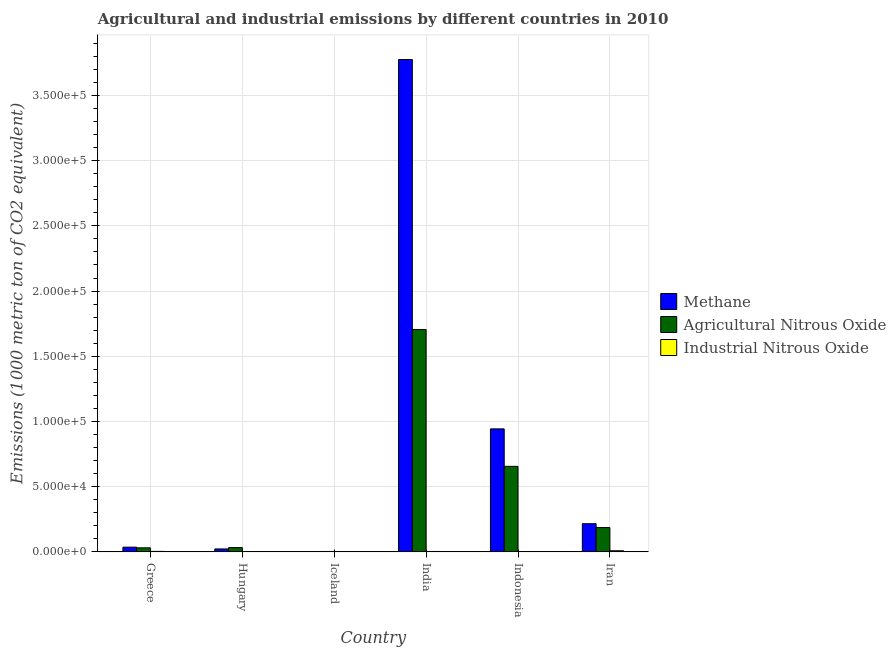How many different coloured bars are there?
Your answer should be very brief. 3. How many groups of bars are there?
Give a very brief answer. 6. How many bars are there on the 1st tick from the right?
Give a very brief answer. 3. What is the label of the 5th group of bars from the left?
Provide a short and direct response. Indonesia. What is the amount of agricultural nitrous oxide emissions in Iceland?
Ensure brevity in your answer.  311.8. Across all countries, what is the maximum amount of agricultural nitrous oxide emissions?
Give a very brief answer. 1.71e+05. Across all countries, what is the minimum amount of industrial nitrous oxide emissions?
Offer a very short reply. 12.5. In which country was the amount of industrial nitrous oxide emissions maximum?
Ensure brevity in your answer.  Iran. In which country was the amount of agricultural nitrous oxide emissions minimum?
Your answer should be compact. Iceland. What is the total amount of methane emissions in the graph?
Give a very brief answer. 5.00e+05. What is the difference between the amount of methane emissions in Hungary and that in Indonesia?
Offer a very short reply. -9.21e+04. What is the difference between the amount of industrial nitrous oxide emissions in Iceland and the amount of agricultural nitrous oxide emissions in Greece?
Your answer should be compact. -3089.4. What is the average amount of industrial nitrous oxide emissions per country?
Make the answer very short. 303.15. What is the difference between the amount of industrial nitrous oxide emissions and amount of agricultural nitrous oxide emissions in Indonesia?
Offer a very short reply. -6.54e+04. What is the ratio of the amount of agricultural nitrous oxide emissions in Iceland to that in Iran?
Offer a very short reply. 0.02. What is the difference between the highest and the second highest amount of agricultural nitrous oxide emissions?
Keep it short and to the point. 1.05e+05. What is the difference between the highest and the lowest amount of methane emissions?
Your answer should be very brief. 3.77e+05. What does the 1st bar from the left in Hungary represents?
Your response must be concise. Methane. What does the 3rd bar from the right in India represents?
Ensure brevity in your answer.  Methane. Is it the case that in every country, the sum of the amount of methane emissions and amount of agricultural nitrous oxide emissions is greater than the amount of industrial nitrous oxide emissions?
Make the answer very short. Yes. How many countries are there in the graph?
Your answer should be compact. 6. Does the graph contain any zero values?
Offer a terse response. No. Does the graph contain grids?
Your response must be concise. Yes. How are the legend labels stacked?
Offer a terse response. Vertical. What is the title of the graph?
Offer a terse response. Agricultural and industrial emissions by different countries in 2010. What is the label or title of the Y-axis?
Give a very brief answer. Emissions (1000 metric ton of CO2 equivalent). What is the Emissions (1000 metric ton of CO2 equivalent) of Methane in Greece?
Make the answer very short. 3622.4. What is the Emissions (1000 metric ton of CO2 equivalent) in Agricultural Nitrous Oxide in Greece?
Offer a terse response. 3107.1. What is the Emissions (1000 metric ton of CO2 equivalent) in Industrial Nitrous Oxide in Greece?
Ensure brevity in your answer.  372.7. What is the Emissions (1000 metric ton of CO2 equivalent) of Methane in Hungary?
Your response must be concise. 2250. What is the Emissions (1000 metric ton of CO2 equivalent) in Agricultural Nitrous Oxide in Hungary?
Make the answer very short. 3293.7. What is the Emissions (1000 metric ton of CO2 equivalent) of Methane in Iceland?
Provide a succinct answer. 212.4. What is the Emissions (1000 metric ton of CO2 equivalent) in Agricultural Nitrous Oxide in Iceland?
Provide a short and direct response. 311.8. What is the Emissions (1000 metric ton of CO2 equivalent) in Industrial Nitrous Oxide in Iceland?
Your answer should be compact. 17.7. What is the Emissions (1000 metric ton of CO2 equivalent) of Methane in India?
Ensure brevity in your answer.  3.78e+05. What is the Emissions (1000 metric ton of CO2 equivalent) in Agricultural Nitrous Oxide in India?
Your answer should be compact. 1.71e+05. What is the Emissions (1000 metric ton of CO2 equivalent) in Industrial Nitrous Oxide in India?
Ensure brevity in your answer.  314.9. What is the Emissions (1000 metric ton of CO2 equivalent) in Methane in Indonesia?
Give a very brief answer. 9.43e+04. What is the Emissions (1000 metric ton of CO2 equivalent) in Agricultural Nitrous Oxide in Indonesia?
Your answer should be very brief. 6.56e+04. What is the Emissions (1000 metric ton of CO2 equivalent) in Industrial Nitrous Oxide in Indonesia?
Your answer should be compact. 218.6. What is the Emissions (1000 metric ton of CO2 equivalent) of Methane in Iran?
Provide a short and direct response. 2.16e+04. What is the Emissions (1000 metric ton of CO2 equivalent) in Agricultural Nitrous Oxide in Iran?
Offer a very short reply. 1.86e+04. What is the Emissions (1000 metric ton of CO2 equivalent) of Industrial Nitrous Oxide in Iran?
Offer a very short reply. 882.5. Across all countries, what is the maximum Emissions (1000 metric ton of CO2 equivalent) in Methane?
Make the answer very short. 3.78e+05. Across all countries, what is the maximum Emissions (1000 metric ton of CO2 equivalent) of Agricultural Nitrous Oxide?
Offer a terse response. 1.71e+05. Across all countries, what is the maximum Emissions (1000 metric ton of CO2 equivalent) in Industrial Nitrous Oxide?
Your answer should be compact. 882.5. Across all countries, what is the minimum Emissions (1000 metric ton of CO2 equivalent) in Methane?
Keep it short and to the point. 212.4. Across all countries, what is the minimum Emissions (1000 metric ton of CO2 equivalent) of Agricultural Nitrous Oxide?
Your answer should be compact. 311.8. What is the total Emissions (1000 metric ton of CO2 equivalent) of Methane in the graph?
Give a very brief answer. 5.00e+05. What is the total Emissions (1000 metric ton of CO2 equivalent) in Agricultural Nitrous Oxide in the graph?
Keep it short and to the point. 2.61e+05. What is the total Emissions (1000 metric ton of CO2 equivalent) in Industrial Nitrous Oxide in the graph?
Keep it short and to the point. 1818.9. What is the difference between the Emissions (1000 metric ton of CO2 equivalent) of Methane in Greece and that in Hungary?
Ensure brevity in your answer.  1372.4. What is the difference between the Emissions (1000 metric ton of CO2 equivalent) in Agricultural Nitrous Oxide in Greece and that in Hungary?
Offer a terse response. -186.6. What is the difference between the Emissions (1000 metric ton of CO2 equivalent) of Industrial Nitrous Oxide in Greece and that in Hungary?
Make the answer very short. 360.2. What is the difference between the Emissions (1000 metric ton of CO2 equivalent) of Methane in Greece and that in Iceland?
Your answer should be very brief. 3410. What is the difference between the Emissions (1000 metric ton of CO2 equivalent) in Agricultural Nitrous Oxide in Greece and that in Iceland?
Ensure brevity in your answer.  2795.3. What is the difference between the Emissions (1000 metric ton of CO2 equivalent) in Industrial Nitrous Oxide in Greece and that in Iceland?
Offer a terse response. 355. What is the difference between the Emissions (1000 metric ton of CO2 equivalent) in Methane in Greece and that in India?
Provide a succinct answer. -3.74e+05. What is the difference between the Emissions (1000 metric ton of CO2 equivalent) of Agricultural Nitrous Oxide in Greece and that in India?
Ensure brevity in your answer.  -1.67e+05. What is the difference between the Emissions (1000 metric ton of CO2 equivalent) in Industrial Nitrous Oxide in Greece and that in India?
Ensure brevity in your answer.  57.8. What is the difference between the Emissions (1000 metric ton of CO2 equivalent) of Methane in Greece and that in Indonesia?
Provide a short and direct response. -9.07e+04. What is the difference between the Emissions (1000 metric ton of CO2 equivalent) in Agricultural Nitrous Oxide in Greece and that in Indonesia?
Your response must be concise. -6.25e+04. What is the difference between the Emissions (1000 metric ton of CO2 equivalent) of Industrial Nitrous Oxide in Greece and that in Indonesia?
Provide a short and direct response. 154.1. What is the difference between the Emissions (1000 metric ton of CO2 equivalent) in Methane in Greece and that in Iran?
Your response must be concise. -1.80e+04. What is the difference between the Emissions (1000 metric ton of CO2 equivalent) of Agricultural Nitrous Oxide in Greece and that in Iran?
Your answer should be very brief. -1.55e+04. What is the difference between the Emissions (1000 metric ton of CO2 equivalent) in Industrial Nitrous Oxide in Greece and that in Iran?
Give a very brief answer. -509.8. What is the difference between the Emissions (1000 metric ton of CO2 equivalent) of Methane in Hungary and that in Iceland?
Make the answer very short. 2037.6. What is the difference between the Emissions (1000 metric ton of CO2 equivalent) of Agricultural Nitrous Oxide in Hungary and that in Iceland?
Your answer should be compact. 2981.9. What is the difference between the Emissions (1000 metric ton of CO2 equivalent) in Industrial Nitrous Oxide in Hungary and that in Iceland?
Offer a very short reply. -5.2. What is the difference between the Emissions (1000 metric ton of CO2 equivalent) in Methane in Hungary and that in India?
Your answer should be compact. -3.75e+05. What is the difference between the Emissions (1000 metric ton of CO2 equivalent) of Agricultural Nitrous Oxide in Hungary and that in India?
Your answer should be very brief. -1.67e+05. What is the difference between the Emissions (1000 metric ton of CO2 equivalent) of Industrial Nitrous Oxide in Hungary and that in India?
Ensure brevity in your answer.  -302.4. What is the difference between the Emissions (1000 metric ton of CO2 equivalent) of Methane in Hungary and that in Indonesia?
Provide a succinct answer. -9.21e+04. What is the difference between the Emissions (1000 metric ton of CO2 equivalent) in Agricultural Nitrous Oxide in Hungary and that in Indonesia?
Ensure brevity in your answer.  -6.23e+04. What is the difference between the Emissions (1000 metric ton of CO2 equivalent) of Industrial Nitrous Oxide in Hungary and that in Indonesia?
Your answer should be compact. -206.1. What is the difference between the Emissions (1000 metric ton of CO2 equivalent) of Methane in Hungary and that in Iran?
Your response must be concise. -1.93e+04. What is the difference between the Emissions (1000 metric ton of CO2 equivalent) of Agricultural Nitrous Oxide in Hungary and that in Iran?
Provide a succinct answer. -1.53e+04. What is the difference between the Emissions (1000 metric ton of CO2 equivalent) of Industrial Nitrous Oxide in Hungary and that in Iran?
Ensure brevity in your answer.  -870. What is the difference between the Emissions (1000 metric ton of CO2 equivalent) in Methane in Iceland and that in India?
Make the answer very short. -3.77e+05. What is the difference between the Emissions (1000 metric ton of CO2 equivalent) in Agricultural Nitrous Oxide in Iceland and that in India?
Provide a succinct answer. -1.70e+05. What is the difference between the Emissions (1000 metric ton of CO2 equivalent) of Industrial Nitrous Oxide in Iceland and that in India?
Make the answer very short. -297.2. What is the difference between the Emissions (1000 metric ton of CO2 equivalent) of Methane in Iceland and that in Indonesia?
Your answer should be very brief. -9.41e+04. What is the difference between the Emissions (1000 metric ton of CO2 equivalent) of Agricultural Nitrous Oxide in Iceland and that in Indonesia?
Make the answer very short. -6.53e+04. What is the difference between the Emissions (1000 metric ton of CO2 equivalent) of Industrial Nitrous Oxide in Iceland and that in Indonesia?
Provide a short and direct response. -200.9. What is the difference between the Emissions (1000 metric ton of CO2 equivalent) of Methane in Iceland and that in Iran?
Make the answer very short. -2.14e+04. What is the difference between the Emissions (1000 metric ton of CO2 equivalent) of Agricultural Nitrous Oxide in Iceland and that in Iran?
Make the answer very short. -1.83e+04. What is the difference between the Emissions (1000 metric ton of CO2 equivalent) in Industrial Nitrous Oxide in Iceland and that in Iran?
Your response must be concise. -864.8. What is the difference between the Emissions (1000 metric ton of CO2 equivalent) of Methane in India and that in Indonesia?
Offer a terse response. 2.83e+05. What is the difference between the Emissions (1000 metric ton of CO2 equivalent) of Agricultural Nitrous Oxide in India and that in Indonesia?
Your answer should be very brief. 1.05e+05. What is the difference between the Emissions (1000 metric ton of CO2 equivalent) of Industrial Nitrous Oxide in India and that in Indonesia?
Provide a succinct answer. 96.3. What is the difference between the Emissions (1000 metric ton of CO2 equivalent) of Methane in India and that in Iran?
Offer a terse response. 3.56e+05. What is the difference between the Emissions (1000 metric ton of CO2 equivalent) of Agricultural Nitrous Oxide in India and that in Iran?
Ensure brevity in your answer.  1.52e+05. What is the difference between the Emissions (1000 metric ton of CO2 equivalent) of Industrial Nitrous Oxide in India and that in Iran?
Provide a succinct answer. -567.6. What is the difference between the Emissions (1000 metric ton of CO2 equivalent) of Methane in Indonesia and that in Iran?
Your answer should be very brief. 7.27e+04. What is the difference between the Emissions (1000 metric ton of CO2 equivalent) in Agricultural Nitrous Oxide in Indonesia and that in Iran?
Keep it short and to the point. 4.69e+04. What is the difference between the Emissions (1000 metric ton of CO2 equivalent) of Industrial Nitrous Oxide in Indonesia and that in Iran?
Ensure brevity in your answer.  -663.9. What is the difference between the Emissions (1000 metric ton of CO2 equivalent) of Methane in Greece and the Emissions (1000 metric ton of CO2 equivalent) of Agricultural Nitrous Oxide in Hungary?
Make the answer very short. 328.7. What is the difference between the Emissions (1000 metric ton of CO2 equivalent) of Methane in Greece and the Emissions (1000 metric ton of CO2 equivalent) of Industrial Nitrous Oxide in Hungary?
Ensure brevity in your answer.  3609.9. What is the difference between the Emissions (1000 metric ton of CO2 equivalent) of Agricultural Nitrous Oxide in Greece and the Emissions (1000 metric ton of CO2 equivalent) of Industrial Nitrous Oxide in Hungary?
Your answer should be very brief. 3094.6. What is the difference between the Emissions (1000 metric ton of CO2 equivalent) of Methane in Greece and the Emissions (1000 metric ton of CO2 equivalent) of Agricultural Nitrous Oxide in Iceland?
Your answer should be very brief. 3310.6. What is the difference between the Emissions (1000 metric ton of CO2 equivalent) in Methane in Greece and the Emissions (1000 metric ton of CO2 equivalent) in Industrial Nitrous Oxide in Iceland?
Your answer should be compact. 3604.7. What is the difference between the Emissions (1000 metric ton of CO2 equivalent) of Agricultural Nitrous Oxide in Greece and the Emissions (1000 metric ton of CO2 equivalent) of Industrial Nitrous Oxide in Iceland?
Provide a succinct answer. 3089.4. What is the difference between the Emissions (1000 metric ton of CO2 equivalent) in Methane in Greece and the Emissions (1000 metric ton of CO2 equivalent) in Agricultural Nitrous Oxide in India?
Provide a succinct answer. -1.67e+05. What is the difference between the Emissions (1000 metric ton of CO2 equivalent) of Methane in Greece and the Emissions (1000 metric ton of CO2 equivalent) of Industrial Nitrous Oxide in India?
Provide a short and direct response. 3307.5. What is the difference between the Emissions (1000 metric ton of CO2 equivalent) in Agricultural Nitrous Oxide in Greece and the Emissions (1000 metric ton of CO2 equivalent) in Industrial Nitrous Oxide in India?
Offer a terse response. 2792.2. What is the difference between the Emissions (1000 metric ton of CO2 equivalent) in Methane in Greece and the Emissions (1000 metric ton of CO2 equivalent) in Agricultural Nitrous Oxide in Indonesia?
Provide a short and direct response. -6.20e+04. What is the difference between the Emissions (1000 metric ton of CO2 equivalent) of Methane in Greece and the Emissions (1000 metric ton of CO2 equivalent) of Industrial Nitrous Oxide in Indonesia?
Provide a succinct answer. 3403.8. What is the difference between the Emissions (1000 metric ton of CO2 equivalent) of Agricultural Nitrous Oxide in Greece and the Emissions (1000 metric ton of CO2 equivalent) of Industrial Nitrous Oxide in Indonesia?
Provide a succinct answer. 2888.5. What is the difference between the Emissions (1000 metric ton of CO2 equivalent) in Methane in Greece and the Emissions (1000 metric ton of CO2 equivalent) in Agricultural Nitrous Oxide in Iran?
Make the answer very short. -1.50e+04. What is the difference between the Emissions (1000 metric ton of CO2 equivalent) in Methane in Greece and the Emissions (1000 metric ton of CO2 equivalent) in Industrial Nitrous Oxide in Iran?
Your answer should be compact. 2739.9. What is the difference between the Emissions (1000 metric ton of CO2 equivalent) of Agricultural Nitrous Oxide in Greece and the Emissions (1000 metric ton of CO2 equivalent) of Industrial Nitrous Oxide in Iran?
Make the answer very short. 2224.6. What is the difference between the Emissions (1000 metric ton of CO2 equivalent) of Methane in Hungary and the Emissions (1000 metric ton of CO2 equivalent) of Agricultural Nitrous Oxide in Iceland?
Offer a terse response. 1938.2. What is the difference between the Emissions (1000 metric ton of CO2 equivalent) in Methane in Hungary and the Emissions (1000 metric ton of CO2 equivalent) in Industrial Nitrous Oxide in Iceland?
Your answer should be very brief. 2232.3. What is the difference between the Emissions (1000 metric ton of CO2 equivalent) of Agricultural Nitrous Oxide in Hungary and the Emissions (1000 metric ton of CO2 equivalent) of Industrial Nitrous Oxide in Iceland?
Provide a succinct answer. 3276. What is the difference between the Emissions (1000 metric ton of CO2 equivalent) of Methane in Hungary and the Emissions (1000 metric ton of CO2 equivalent) of Agricultural Nitrous Oxide in India?
Ensure brevity in your answer.  -1.68e+05. What is the difference between the Emissions (1000 metric ton of CO2 equivalent) in Methane in Hungary and the Emissions (1000 metric ton of CO2 equivalent) in Industrial Nitrous Oxide in India?
Your answer should be very brief. 1935.1. What is the difference between the Emissions (1000 metric ton of CO2 equivalent) of Agricultural Nitrous Oxide in Hungary and the Emissions (1000 metric ton of CO2 equivalent) of Industrial Nitrous Oxide in India?
Your answer should be compact. 2978.8. What is the difference between the Emissions (1000 metric ton of CO2 equivalent) in Methane in Hungary and the Emissions (1000 metric ton of CO2 equivalent) in Agricultural Nitrous Oxide in Indonesia?
Make the answer very short. -6.33e+04. What is the difference between the Emissions (1000 metric ton of CO2 equivalent) of Methane in Hungary and the Emissions (1000 metric ton of CO2 equivalent) of Industrial Nitrous Oxide in Indonesia?
Offer a terse response. 2031.4. What is the difference between the Emissions (1000 metric ton of CO2 equivalent) of Agricultural Nitrous Oxide in Hungary and the Emissions (1000 metric ton of CO2 equivalent) of Industrial Nitrous Oxide in Indonesia?
Ensure brevity in your answer.  3075.1. What is the difference between the Emissions (1000 metric ton of CO2 equivalent) in Methane in Hungary and the Emissions (1000 metric ton of CO2 equivalent) in Agricultural Nitrous Oxide in Iran?
Offer a very short reply. -1.64e+04. What is the difference between the Emissions (1000 metric ton of CO2 equivalent) in Methane in Hungary and the Emissions (1000 metric ton of CO2 equivalent) in Industrial Nitrous Oxide in Iran?
Your answer should be very brief. 1367.5. What is the difference between the Emissions (1000 metric ton of CO2 equivalent) in Agricultural Nitrous Oxide in Hungary and the Emissions (1000 metric ton of CO2 equivalent) in Industrial Nitrous Oxide in Iran?
Make the answer very short. 2411.2. What is the difference between the Emissions (1000 metric ton of CO2 equivalent) of Methane in Iceland and the Emissions (1000 metric ton of CO2 equivalent) of Agricultural Nitrous Oxide in India?
Give a very brief answer. -1.70e+05. What is the difference between the Emissions (1000 metric ton of CO2 equivalent) in Methane in Iceland and the Emissions (1000 metric ton of CO2 equivalent) in Industrial Nitrous Oxide in India?
Your answer should be compact. -102.5. What is the difference between the Emissions (1000 metric ton of CO2 equivalent) in Agricultural Nitrous Oxide in Iceland and the Emissions (1000 metric ton of CO2 equivalent) in Industrial Nitrous Oxide in India?
Give a very brief answer. -3.1. What is the difference between the Emissions (1000 metric ton of CO2 equivalent) in Methane in Iceland and the Emissions (1000 metric ton of CO2 equivalent) in Agricultural Nitrous Oxide in Indonesia?
Your answer should be very brief. -6.54e+04. What is the difference between the Emissions (1000 metric ton of CO2 equivalent) of Agricultural Nitrous Oxide in Iceland and the Emissions (1000 metric ton of CO2 equivalent) of Industrial Nitrous Oxide in Indonesia?
Your answer should be very brief. 93.2. What is the difference between the Emissions (1000 metric ton of CO2 equivalent) in Methane in Iceland and the Emissions (1000 metric ton of CO2 equivalent) in Agricultural Nitrous Oxide in Iran?
Give a very brief answer. -1.84e+04. What is the difference between the Emissions (1000 metric ton of CO2 equivalent) of Methane in Iceland and the Emissions (1000 metric ton of CO2 equivalent) of Industrial Nitrous Oxide in Iran?
Give a very brief answer. -670.1. What is the difference between the Emissions (1000 metric ton of CO2 equivalent) of Agricultural Nitrous Oxide in Iceland and the Emissions (1000 metric ton of CO2 equivalent) of Industrial Nitrous Oxide in Iran?
Provide a short and direct response. -570.7. What is the difference between the Emissions (1000 metric ton of CO2 equivalent) of Methane in India and the Emissions (1000 metric ton of CO2 equivalent) of Agricultural Nitrous Oxide in Indonesia?
Keep it short and to the point. 3.12e+05. What is the difference between the Emissions (1000 metric ton of CO2 equivalent) in Methane in India and the Emissions (1000 metric ton of CO2 equivalent) in Industrial Nitrous Oxide in Indonesia?
Your answer should be compact. 3.77e+05. What is the difference between the Emissions (1000 metric ton of CO2 equivalent) of Agricultural Nitrous Oxide in India and the Emissions (1000 metric ton of CO2 equivalent) of Industrial Nitrous Oxide in Indonesia?
Provide a short and direct response. 1.70e+05. What is the difference between the Emissions (1000 metric ton of CO2 equivalent) in Methane in India and the Emissions (1000 metric ton of CO2 equivalent) in Agricultural Nitrous Oxide in Iran?
Offer a terse response. 3.59e+05. What is the difference between the Emissions (1000 metric ton of CO2 equivalent) of Methane in India and the Emissions (1000 metric ton of CO2 equivalent) of Industrial Nitrous Oxide in Iran?
Your answer should be compact. 3.77e+05. What is the difference between the Emissions (1000 metric ton of CO2 equivalent) of Agricultural Nitrous Oxide in India and the Emissions (1000 metric ton of CO2 equivalent) of Industrial Nitrous Oxide in Iran?
Keep it short and to the point. 1.70e+05. What is the difference between the Emissions (1000 metric ton of CO2 equivalent) of Methane in Indonesia and the Emissions (1000 metric ton of CO2 equivalent) of Agricultural Nitrous Oxide in Iran?
Give a very brief answer. 7.57e+04. What is the difference between the Emissions (1000 metric ton of CO2 equivalent) in Methane in Indonesia and the Emissions (1000 metric ton of CO2 equivalent) in Industrial Nitrous Oxide in Iran?
Give a very brief answer. 9.34e+04. What is the difference between the Emissions (1000 metric ton of CO2 equivalent) in Agricultural Nitrous Oxide in Indonesia and the Emissions (1000 metric ton of CO2 equivalent) in Industrial Nitrous Oxide in Iran?
Ensure brevity in your answer.  6.47e+04. What is the average Emissions (1000 metric ton of CO2 equivalent) of Methane per country?
Offer a terse response. 8.33e+04. What is the average Emissions (1000 metric ton of CO2 equivalent) of Agricultural Nitrous Oxide per country?
Provide a short and direct response. 4.36e+04. What is the average Emissions (1000 metric ton of CO2 equivalent) of Industrial Nitrous Oxide per country?
Make the answer very short. 303.15. What is the difference between the Emissions (1000 metric ton of CO2 equivalent) in Methane and Emissions (1000 metric ton of CO2 equivalent) in Agricultural Nitrous Oxide in Greece?
Ensure brevity in your answer.  515.3. What is the difference between the Emissions (1000 metric ton of CO2 equivalent) in Methane and Emissions (1000 metric ton of CO2 equivalent) in Industrial Nitrous Oxide in Greece?
Offer a very short reply. 3249.7. What is the difference between the Emissions (1000 metric ton of CO2 equivalent) of Agricultural Nitrous Oxide and Emissions (1000 metric ton of CO2 equivalent) of Industrial Nitrous Oxide in Greece?
Offer a very short reply. 2734.4. What is the difference between the Emissions (1000 metric ton of CO2 equivalent) in Methane and Emissions (1000 metric ton of CO2 equivalent) in Agricultural Nitrous Oxide in Hungary?
Your answer should be compact. -1043.7. What is the difference between the Emissions (1000 metric ton of CO2 equivalent) of Methane and Emissions (1000 metric ton of CO2 equivalent) of Industrial Nitrous Oxide in Hungary?
Your answer should be very brief. 2237.5. What is the difference between the Emissions (1000 metric ton of CO2 equivalent) of Agricultural Nitrous Oxide and Emissions (1000 metric ton of CO2 equivalent) of Industrial Nitrous Oxide in Hungary?
Your response must be concise. 3281.2. What is the difference between the Emissions (1000 metric ton of CO2 equivalent) in Methane and Emissions (1000 metric ton of CO2 equivalent) in Agricultural Nitrous Oxide in Iceland?
Your response must be concise. -99.4. What is the difference between the Emissions (1000 metric ton of CO2 equivalent) of Methane and Emissions (1000 metric ton of CO2 equivalent) of Industrial Nitrous Oxide in Iceland?
Give a very brief answer. 194.7. What is the difference between the Emissions (1000 metric ton of CO2 equivalent) of Agricultural Nitrous Oxide and Emissions (1000 metric ton of CO2 equivalent) of Industrial Nitrous Oxide in Iceland?
Offer a very short reply. 294.1. What is the difference between the Emissions (1000 metric ton of CO2 equivalent) in Methane and Emissions (1000 metric ton of CO2 equivalent) in Agricultural Nitrous Oxide in India?
Your answer should be compact. 2.07e+05. What is the difference between the Emissions (1000 metric ton of CO2 equivalent) of Methane and Emissions (1000 metric ton of CO2 equivalent) of Industrial Nitrous Oxide in India?
Make the answer very short. 3.77e+05. What is the difference between the Emissions (1000 metric ton of CO2 equivalent) in Agricultural Nitrous Oxide and Emissions (1000 metric ton of CO2 equivalent) in Industrial Nitrous Oxide in India?
Ensure brevity in your answer.  1.70e+05. What is the difference between the Emissions (1000 metric ton of CO2 equivalent) in Methane and Emissions (1000 metric ton of CO2 equivalent) in Agricultural Nitrous Oxide in Indonesia?
Offer a very short reply. 2.87e+04. What is the difference between the Emissions (1000 metric ton of CO2 equivalent) in Methane and Emissions (1000 metric ton of CO2 equivalent) in Industrial Nitrous Oxide in Indonesia?
Keep it short and to the point. 9.41e+04. What is the difference between the Emissions (1000 metric ton of CO2 equivalent) in Agricultural Nitrous Oxide and Emissions (1000 metric ton of CO2 equivalent) in Industrial Nitrous Oxide in Indonesia?
Offer a very short reply. 6.54e+04. What is the difference between the Emissions (1000 metric ton of CO2 equivalent) in Methane and Emissions (1000 metric ton of CO2 equivalent) in Agricultural Nitrous Oxide in Iran?
Give a very brief answer. 2955.7. What is the difference between the Emissions (1000 metric ton of CO2 equivalent) in Methane and Emissions (1000 metric ton of CO2 equivalent) in Industrial Nitrous Oxide in Iran?
Make the answer very short. 2.07e+04. What is the difference between the Emissions (1000 metric ton of CO2 equivalent) in Agricultural Nitrous Oxide and Emissions (1000 metric ton of CO2 equivalent) in Industrial Nitrous Oxide in Iran?
Your response must be concise. 1.78e+04. What is the ratio of the Emissions (1000 metric ton of CO2 equivalent) of Methane in Greece to that in Hungary?
Ensure brevity in your answer.  1.61. What is the ratio of the Emissions (1000 metric ton of CO2 equivalent) of Agricultural Nitrous Oxide in Greece to that in Hungary?
Provide a short and direct response. 0.94. What is the ratio of the Emissions (1000 metric ton of CO2 equivalent) in Industrial Nitrous Oxide in Greece to that in Hungary?
Make the answer very short. 29.82. What is the ratio of the Emissions (1000 metric ton of CO2 equivalent) of Methane in Greece to that in Iceland?
Make the answer very short. 17.05. What is the ratio of the Emissions (1000 metric ton of CO2 equivalent) in Agricultural Nitrous Oxide in Greece to that in Iceland?
Make the answer very short. 9.96. What is the ratio of the Emissions (1000 metric ton of CO2 equivalent) in Industrial Nitrous Oxide in Greece to that in Iceland?
Make the answer very short. 21.06. What is the ratio of the Emissions (1000 metric ton of CO2 equivalent) in Methane in Greece to that in India?
Provide a short and direct response. 0.01. What is the ratio of the Emissions (1000 metric ton of CO2 equivalent) in Agricultural Nitrous Oxide in Greece to that in India?
Your answer should be very brief. 0.02. What is the ratio of the Emissions (1000 metric ton of CO2 equivalent) of Industrial Nitrous Oxide in Greece to that in India?
Provide a succinct answer. 1.18. What is the ratio of the Emissions (1000 metric ton of CO2 equivalent) of Methane in Greece to that in Indonesia?
Your answer should be very brief. 0.04. What is the ratio of the Emissions (1000 metric ton of CO2 equivalent) in Agricultural Nitrous Oxide in Greece to that in Indonesia?
Provide a succinct answer. 0.05. What is the ratio of the Emissions (1000 metric ton of CO2 equivalent) in Industrial Nitrous Oxide in Greece to that in Indonesia?
Provide a short and direct response. 1.7. What is the ratio of the Emissions (1000 metric ton of CO2 equivalent) in Methane in Greece to that in Iran?
Ensure brevity in your answer.  0.17. What is the ratio of the Emissions (1000 metric ton of CO2 equivalent) of Industrial Nitrous Oxide in Greece to that in Iran?
Make the answer very short. 0.42. What is the ratio of the Emissions (1000 metric ton of CO2 equivalent) in Methane in Hungary to that in Iceland?
Offer a terse response. 10.59. What is the ratio of the Emissions (1000 metric ton of CO2 equivalent) of Agricultural Nitrous Oxide in Hungary to that in Iceland?
Your answer should be compact. 10.56. What is the ratio of the Emissions (1000 metric ton of CO2 equivalent) in Industrial Nitrous Oxide in Hungary to that in Iceland?
Give a very brief answer. 0.71. What is the ratio of the Emissions (1000 metric ton of CO2 equivalent) in Methane in Hungary to that in India?
Your answer should be very brief. 0.01. What is the ratio of the Emissions (1000 metric ton of CO2 equivalent) of Agricultural Nitrous Oxide in Hungary to that in India?
Offer a very short reply. 0.02. What is the ratio of the Emissions (1000 metric ton of CO2 equivalent) in Industrial Nitrous Oxide in Hungary to that in India?
Provide a succinct answer. 0.04. What is the ratio of the Emissions (1000 metric ton of CO2 equivalent) of Methane in Hungary to that in Indonesia?
Provide a succinct answer. 0.02. What is the ratio of the Emissions (1000 metric ton of CO2 equivalent) of Agricultural Nitrous Oxide in Hungary to that in Indonesia?
Give a very brief answer. 0.05. What is the ratio of the Emissions (1000 metric ton of CO2 equivalent) in Industrial Nitrous Oxide in Hungary to that in Indonesia?
Provide a short and direct response. 0.06. What is the ratio of the Emissions (1000 metric ton of CO2 equivalent) in Methane in Hungary to that in Iran?
Your answer should be compact. 0.1. What is the ratio of the Emissions (1000 metric ton of CO2 equivalent) in Agricultural Nitrous Oxide in Hungary to that in Iran?
Make the answer very short. 0.18. What is the ratio of the Emissions (1000 metric ton of CO2 equivalent) of Industrial Nitrous Oxide in Hungary to that in Iran?
Make the answer very short. 0.01. What is the ratio of the Emissions (1000 metric ton of CO2 equivalent) of Methane in Iceland to that in India?
Provide a short and direct response. 0. What is the ratio of the Emissions (1000 metric ton of CO2 equivalent) of Agricultural Nitrous Oxide in Iceland to that in India?
Your answer should be very brief. 0. What is the ratio of the Emissions (1000 metric ton of CO2 equivalent) of Industrial Nitrous Oxide in Iceland to that in India?
Provide a succinct answer. 0.06. What is the ratio of the Emissions (1000 metric ton of CO2 equivalent) of Methane in Iceland to that in Indonesia?
Provide a succinct answer. 0. What is the ratio of the Emissions (1000 metric ton of CO2 equivalent) in Agricultural Nitrous Oxide in Iceland to that in Indonesia?
Offer a very short reply. 0. What is the ratio of the Emissions (1000 metric ton of CO2 equivalent) in Industrial Nitrous Oxide in Iceland to that in Indonesia?
Your answer should be very brief. 0.08. What is the ratio of the Emissions (1000 metric ton of CO2 equivalent) in Methane in Iceland to that in Iran?
Offer a terse response. 0.01. What is the ratio of the Emissions (1000 metric ton of CO2 equivalent) of Agricultural Nitrous Oxide in Iceland to that in Iran?
Your answer should be compact. 0.02. What is the ratio of the Emissions (1000 metric ton of CO2 equivalent) of Industrial Nitrous Oxide in Iceland to that in Iran?
Your answer should be compact. 0.02. What is the ratio of the Emissions (1000 metric ton of CO2 equivalent) in Methane in India to that in Indonesia?
Offer a very short reply. 4. What is the ratio of the Emissions (1000 metric ton of CO2 equivalent) of Agricultural Nitrous Oxide in India to that in Indonesia?
Make the answer very short. 2.6. What is the ratio of the Emissions (1000 metric ton of CO2 equivalent) in Industrial Nitrous Oxide in India to that in Indonesia?
Your answer should be very brief. 1.44. What is the ratio of the Emissions (1000 metric ton of CO2 equivalent) of Methane in India to that in Iran?
Give a very brief answer. 17.49. What is the ratio of the Emissions (1000 metric ton of CO2 equivalent) of Agricultural Nitrous Oxide in India to that in Iran?
Give a very brief answer. 9.15. What is the ratio of the Emissions (1000 metric ton of CO2 equivalent) in Industrial Nitrous Oxide in India to that in Iran?
Offer a terse response. 0.36. What is the ratio of the Emissions (1000 metric ton of CO2 equivalent) of Methane in Indonesia to that in Iran?
Make the answer very short. 4.37. What is the ratio of the Emissions (1000 metric ton of CO2 equivalent) of Agricultural Nitrous Oxide in Indonesia to that in Iran?
Your response must be concise. 3.52. What is the ratio of the Emissions (1000 metric ton of CO2 equivalent) of Industrial Nitrous Oxide in Indonesia to that in Iran?
Provide a short and direct response. 0.25. What is the difference between the highest and the second highest Emissions (1000 metric ton of CO2 equivalent) in Methane?
Your answer should be compact. 2.83e+05. What is the difference between the highest and the second highest Emissions (1000 metric ton of CO2 equivalent) of Agricultural Nitrous Oxide?
Offer a terse response. 1.05e+05. What is the difference between the highest and the second highest Emissions (1000 metric ton of CO2 equivalent) in Industrial Nitrous Oxide?
Your response must be concise. 509.8. What is the difference between the highest and the lowest Emissions (1000 metric ton of CO2 equivalent) in Methane?
Keep it short and to the point. 3.77e+05. What is the difference between the highest and the lowest Emissions (1000 metric ton of CO2 equivalent) of Agricultural Nitrous Oxide?
Your answer should be very brief. 1.70e+05. What is the difference between the highest and the lowest Emissions (1000 metric ton of CO2 equivalent) in Industrial Nitrous Oxide?
Make the answer very short. 870. 